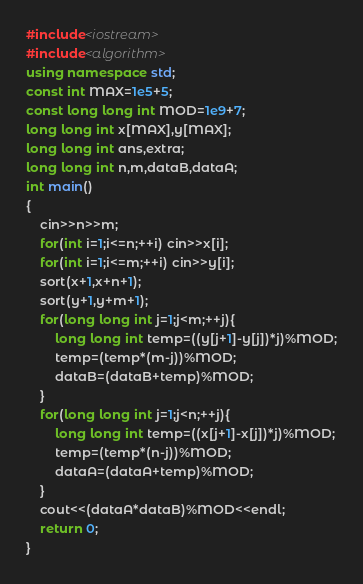<code> <loc_0><loc_0><loc_500><loc_500><_C++_>#include<iostream>
#include<algorithm>
using namespace std;
const int MAX=1e5+5;
const long long int MOD=1e9+7;
long long int x[MAX],y[MAX];
long long int ans,extra;
long long int n,m,dataB,dataA;
int main()
{
	cin>>n>>m;
	for(int i=1;i<=n;++i) cin>>x[i];
	for(int i=1;i<=m;++i) cin>>y[i];
	sort(x+1,x+n+1);
	sort(y+1,y+m+1);
	for(long long int j=1;j<m;++j){
		long long int temp=((y[j+1]-y[j])*j)%MOD;
		temp=(temp*(m-j))%MOD;
		dataB=(dataB+temp)%MOD;
	}
	for(long long int j=1;j<n;++j){
		long long int temp=((x[j+1]-x[j])*j)%MOD;
		temp=(temp*(n-j))%MOD;
		dataA=(dataA+temp)%MOD;
	}
	cout<<(dataA*dataB)%MOD<<endl;
	return 0;
}
</code> 